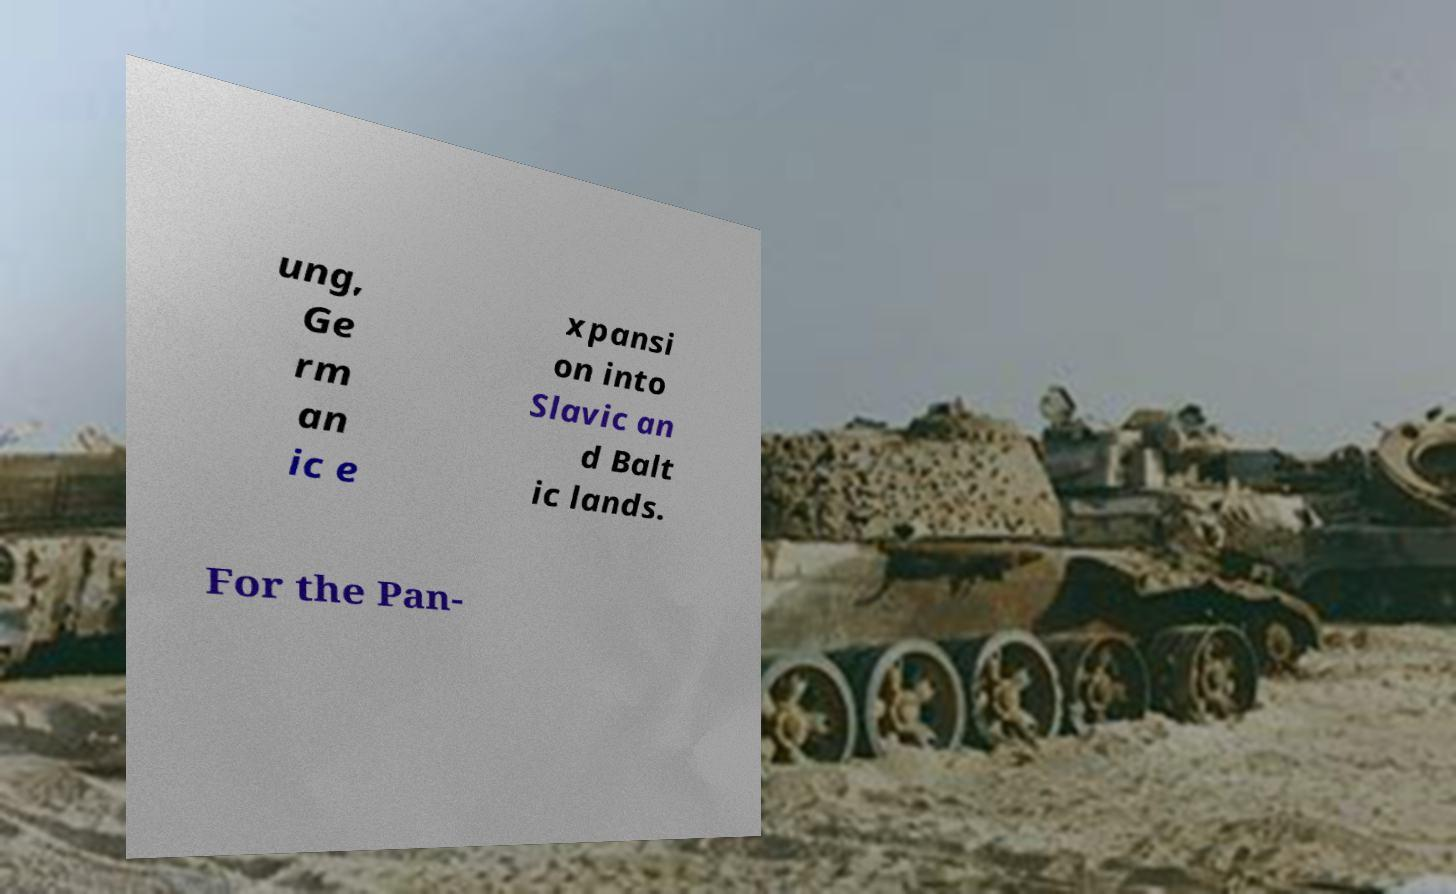What messages or text are displayed in this image? I need them in a readable, typed format. ung, Ge rm an ic e xpansi on into Slavic an d Balt ic lands. For the Pan- 